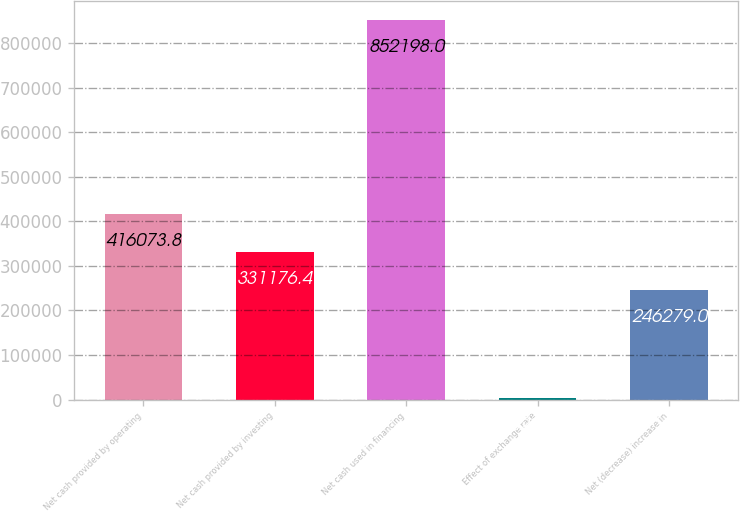Convert chart. <chart><loc_0><loc_0><loc_500><loc_500><bar_chart><fcel>Net cash provided by operating<fcel>Net cash provided by investing<fcel>Net cash used in financing<fcel>Effect of exchange rate<fcel>Net (decrease) increase in<nl><fcel>416074<fcel>331176<fcel>852198<fcel>3224<fcel>246279<nl></chart> 